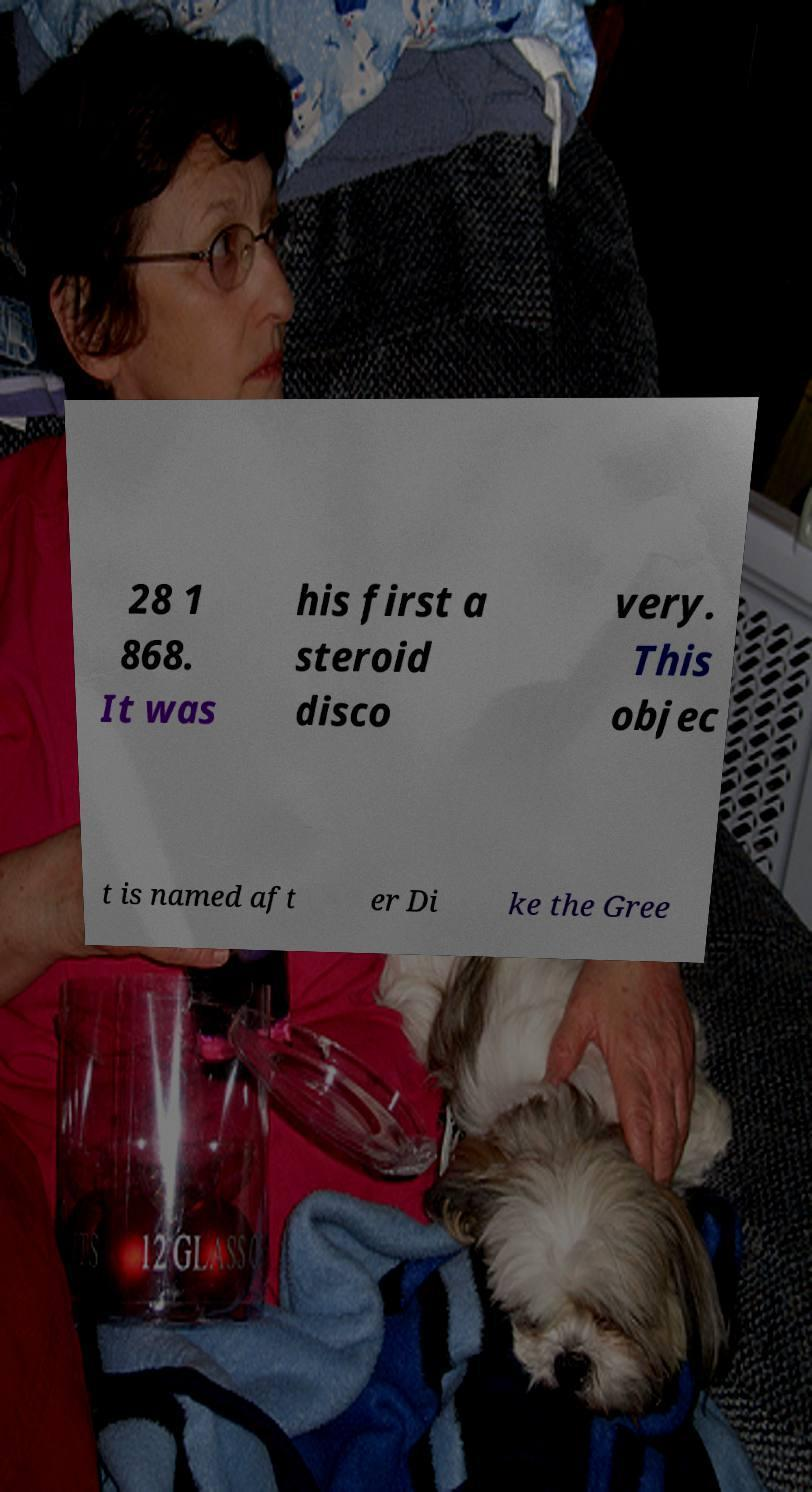I need the written content from this picture converted into text. Can you do that? 28 1 868. It was his first a steroid disco very. This objec t is named aft er Di ke the Gree 